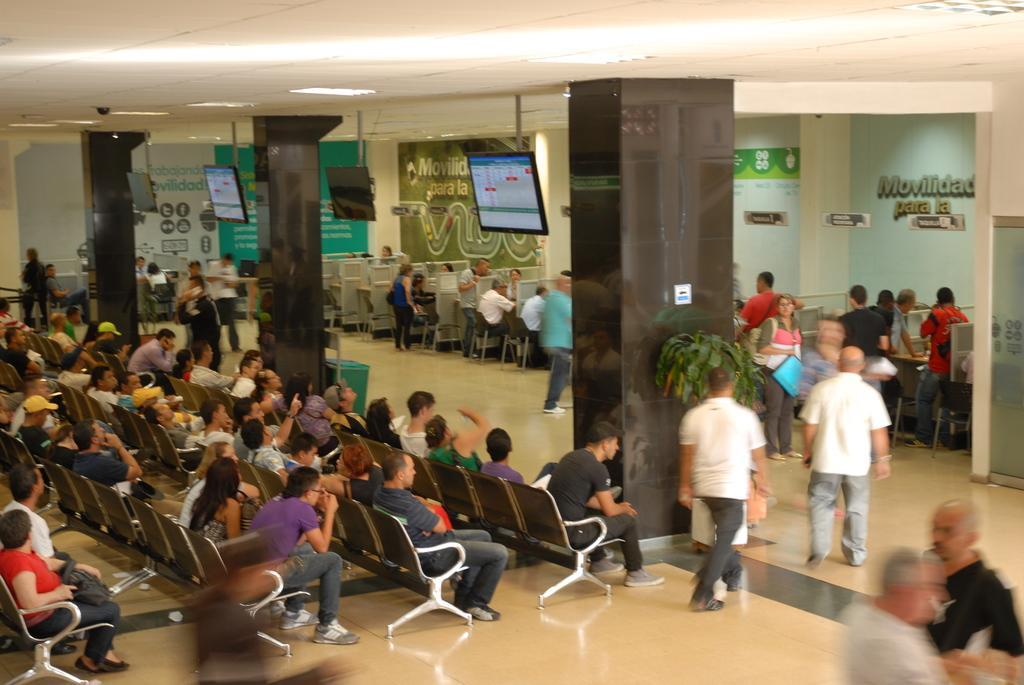Can you describe this image briefly? In this picture we can see some people standing and some people sitting on chairs, there are four screens here, we can see pillars in the middle, there is a plant here, we can see a dustbin behind this pillar, in the background there are some hoardings. 